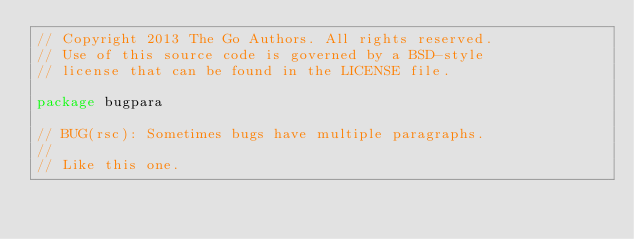<code> <loc_0><loc_0><loc_500><loc_500><_Go_>// Copyright 2013 The Go Authors. All rights reserved.
// Use of this source code is governed by a BSD-style
// license that can be found in the LICENSE file.

package bugpara

// BUG(rsc): Sometimes bugs have multiple paragraphs.
//
// Like this one.
</code> 